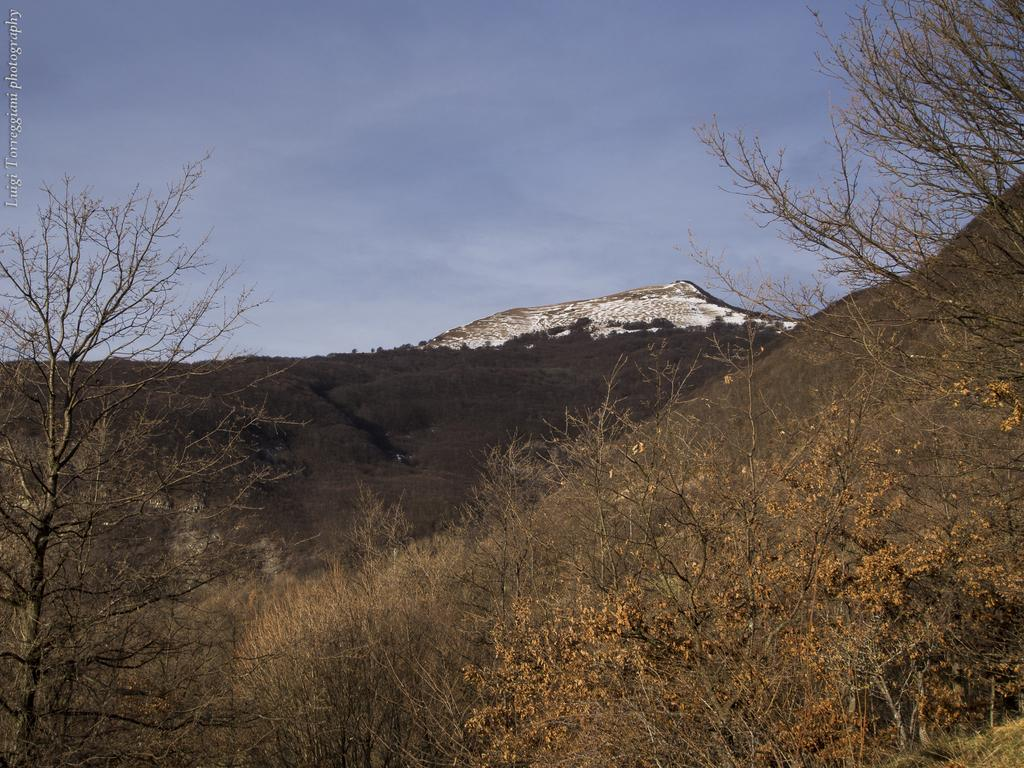What type of vegetation is present at the bottom of the image? There are trees on a hill at the bottom of the image. What geographical features can be seen in the background of the image? There are mountains in the background of the image. What can be seen in the sky in the image? There are clouds in the sky, and the sky is blue. How many birds are perched on the trees at the bottom of the image? There are no birds visible in the image; it only features trees on a hill. What type of rule is being enforced in the image? There is no rule being enforced in the image; it is a landscape scene with trees, mountains, clouds, and a blue sky. 